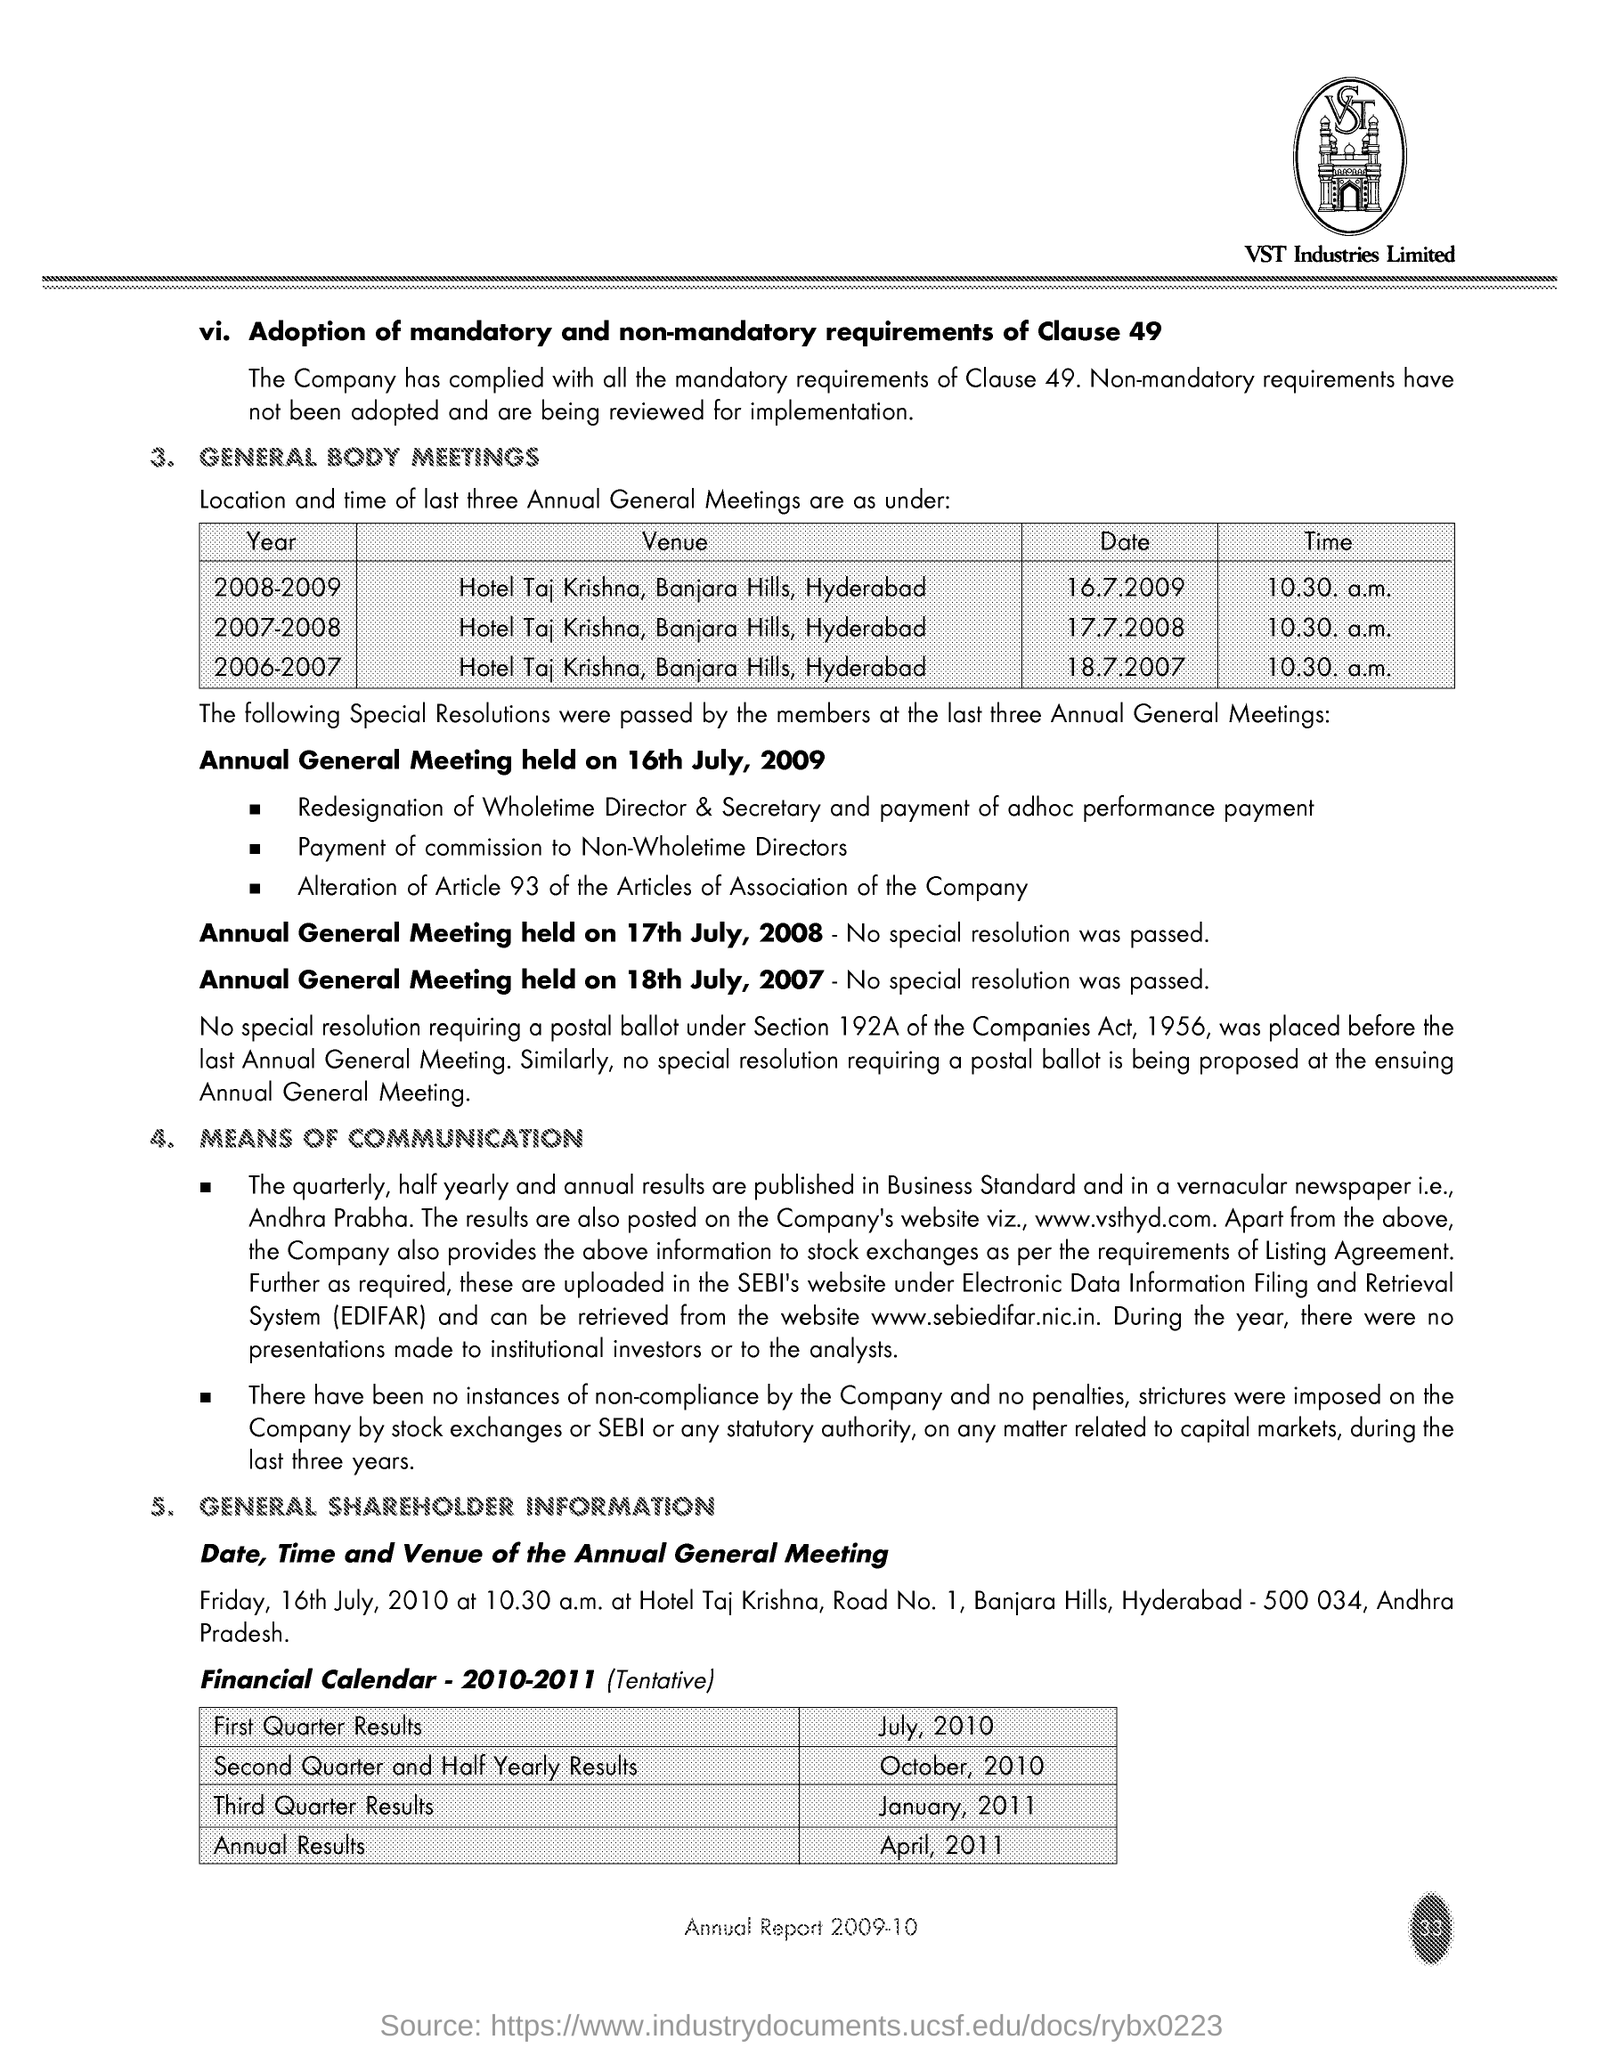What is the Company Name ?
Your answer should be very brief. VST Industries Limited. 